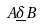Convert formula to latex. <formula><loc_0><loc_0><loc_500><loc_500>A \underline { \delta } B</formula> 